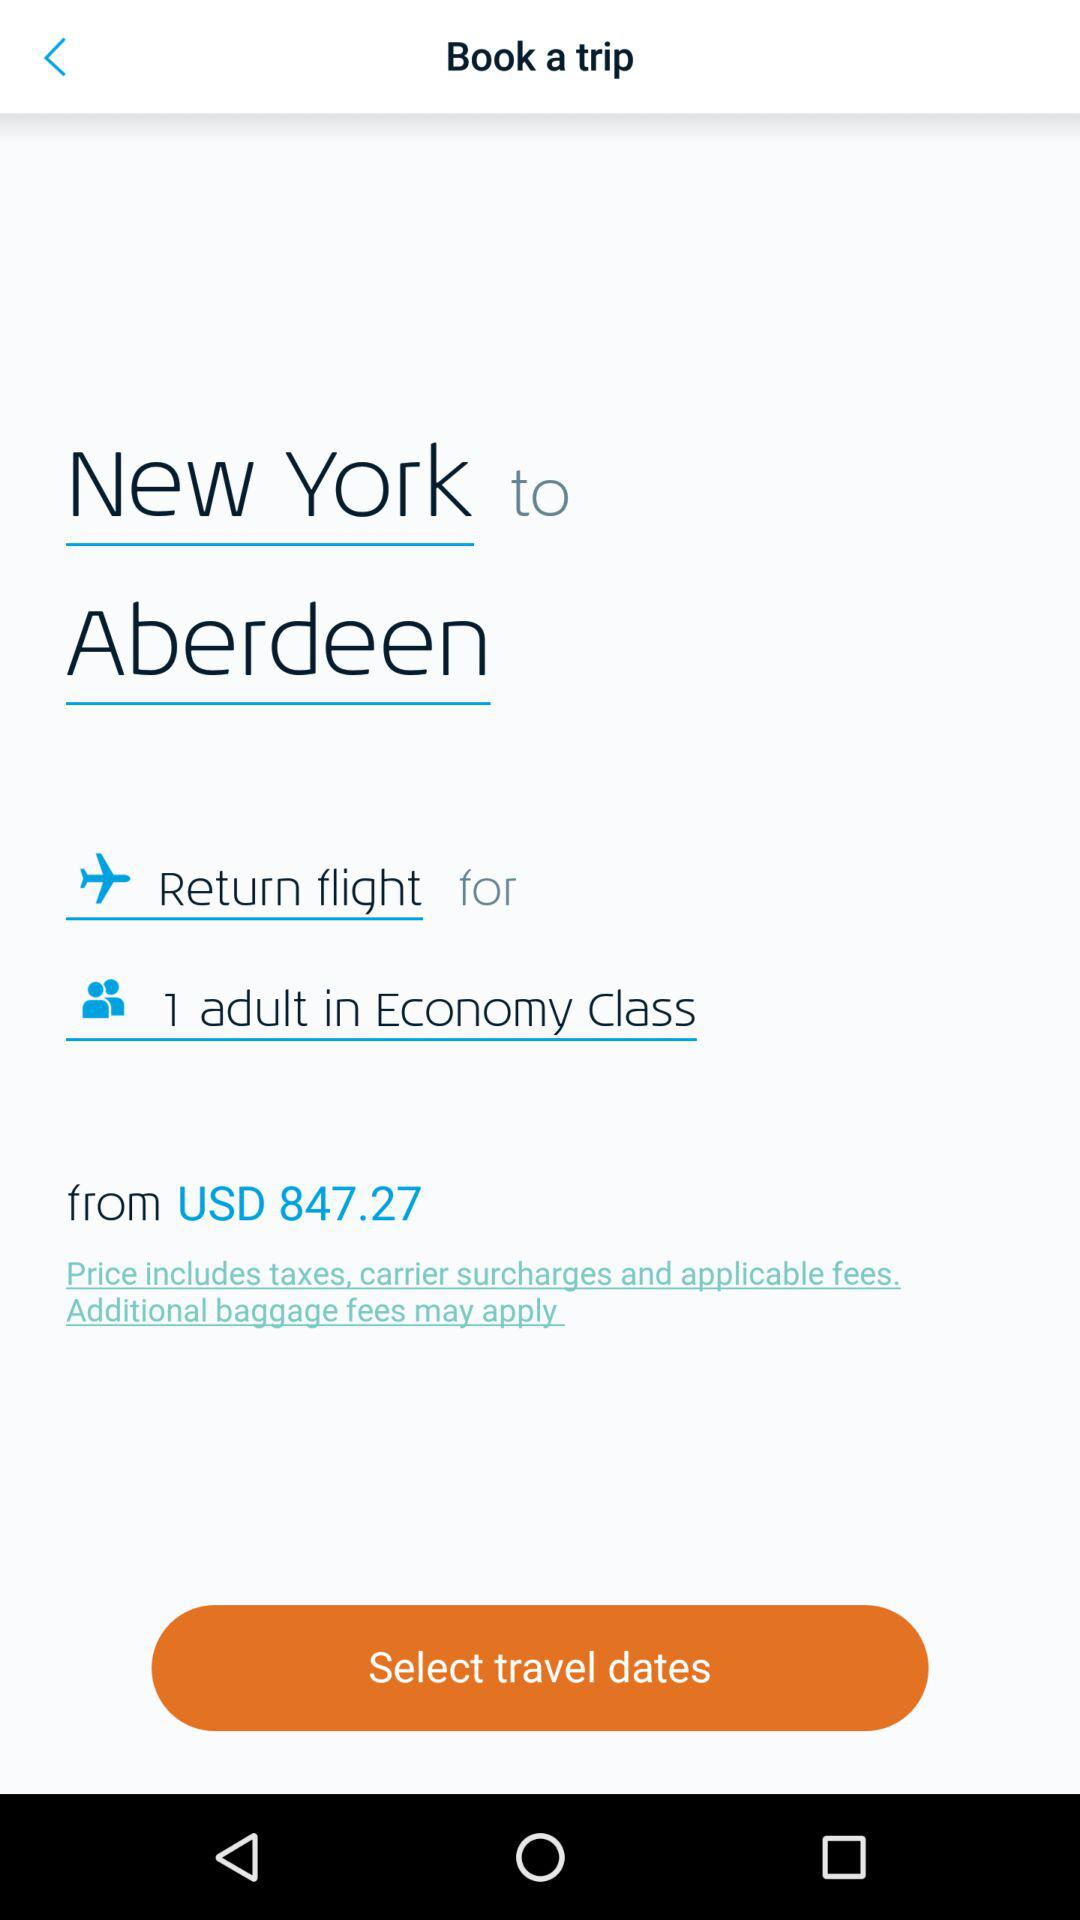How many people are traveling in Economy Class?
Answer the question using a single word or phrase. 1 